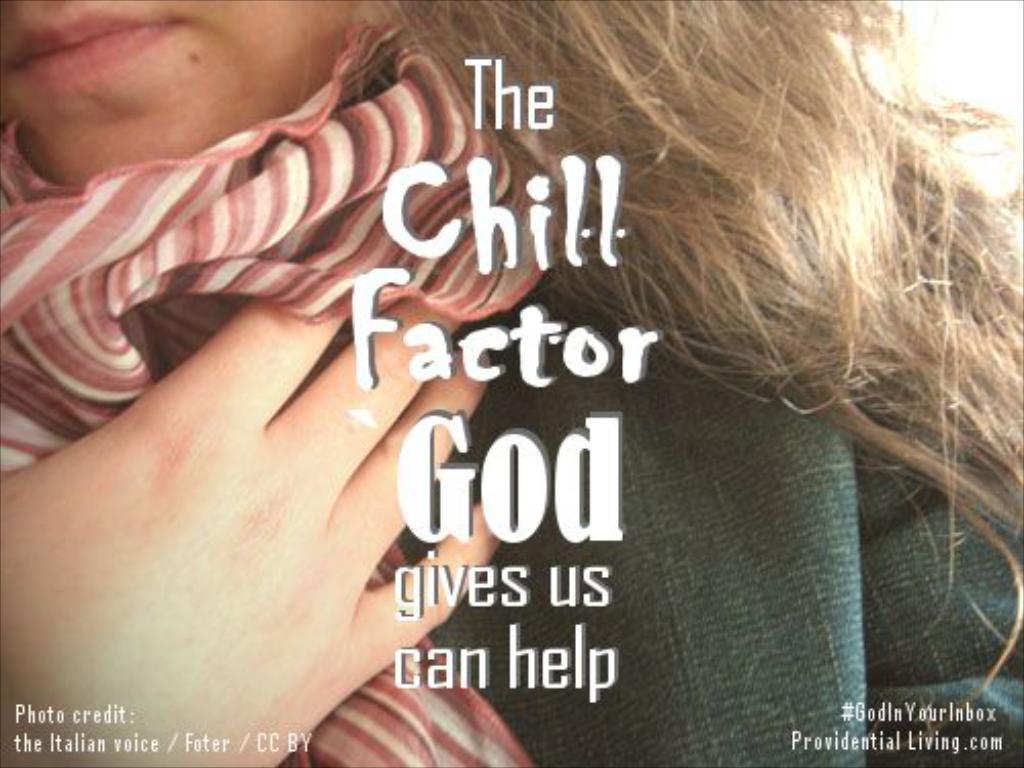Could you give a brief overview of what you see in this image? In the image we can see there is a woman and she is wearing a scarf. There is matter written on the poster. 